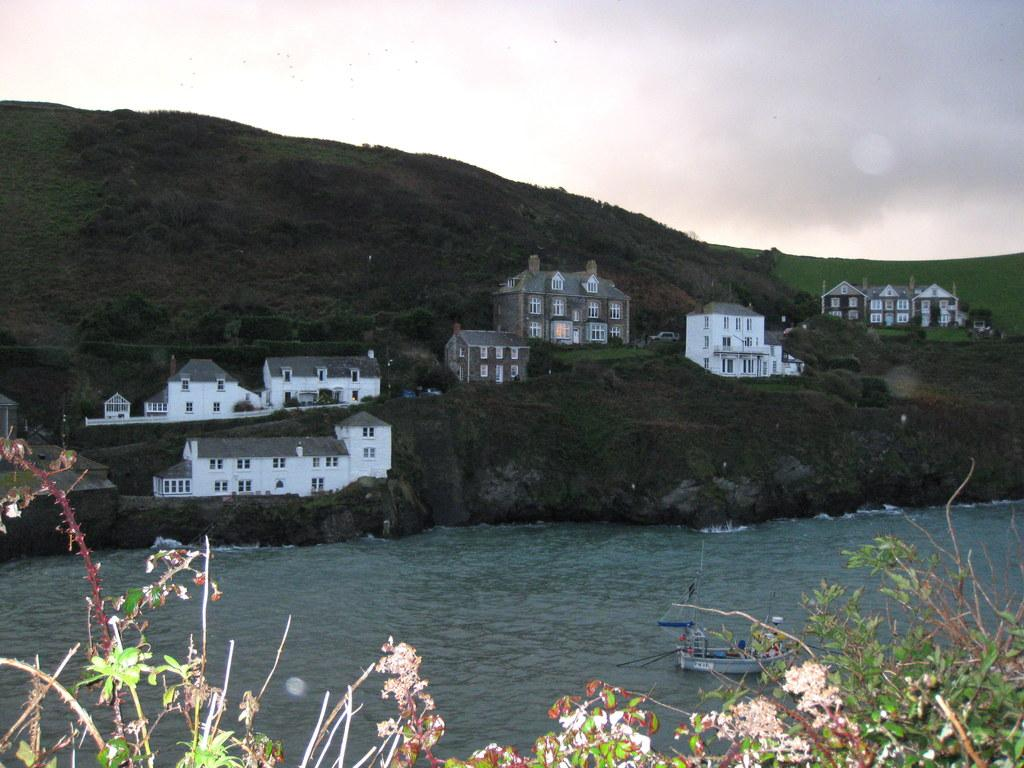What is the main subject of the image? The main subject of the image is a boat. Where is the boat located? The boat is sailing on a river. What else can be seen in the image besides the boat? There are plants, a mountain, houses on the mountain, and the sky visible in the image. Can you see a hole in the boat in the image? There is no hole visible in the boat in the image. What type of fowl is sitting on the mountain in the image? There are no birds or fowl visible on the mountain in the image. 